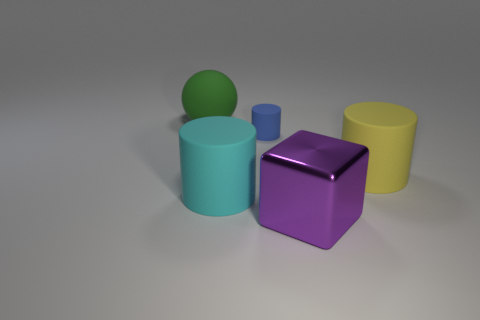Add 1 yellow rubber cylinders. How many objects exist? 6 Subtract all big cylinders. How many cylinders are left? 1 Subtract 1 cylinders. How many cylinders are left? 2 Subtract all blue cylinders. How many cylinders are left? 2 Subtract all balls. How many objects are left? 4 Subtract all brown spheres. Subtract all cyan cylinders. How many spheres are left? 1 Subtract all red spheres. How many cyan cylinders are left? 1 Subtract all large purple shiny cubes. Subtract all large purple metal things. How many objects are left? 3 Add 3 big green balls. How many big green balls are left? 4 Add 2 small blue matte cylinders. How many small blue matte cylinders exist? 3 